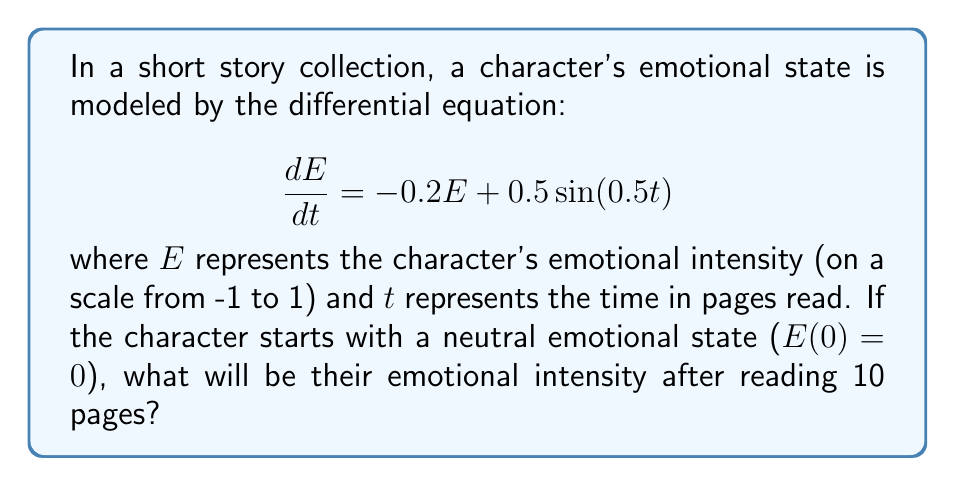Solve this math problem. To solve this problem, we need to use the method for solving first-order linear differential equations. The general form of the equation is:

$$\frac{dE}{dt} + P(t)E = Q(t)$$

In our case, $P(t) = 0.2$ and $Q(t) = 0.5\sin(0.5t)$

1. First, we find the integrating factor:
   $$\mu(t) = e^{\int P(t) dt} = e^{0.2t}$$

2. Multiply both sides of the original equation by the integrating factor:
   $$e^{0.2t}\frac{dE}{dt} + 0.2e^{0.2t}E = 0.5e^{0.2t}\sin(0.5t)$$

3. The left side can be rewritten as the derivative of a product:
   $$\frac{d}{dt}(e^{0.2t}E) = 0.5e^{0.2t}\sin(0.5t)$$

4. Integrate both sides:
   $$e^{0.2t}E = \int 0.5e^{0.2t}\sin(0.5t)dt$$

5. To solve the integral, use integration by parts:
   $$\int 0.5e^{0.2t}\sin(0.5t)dt = 0.5e^{0.2t}(\frac{0.2\sin(0.5t) - 0.5\cos(0.5t)}{0.04 + 0.25}) + C$$

6. Simplify:
   $$e^{0.2t}E = 0.5e^{0.2t}(\frac{0.2\sin(0.5t) - 0.5\cos(0.5t)}{0.29}) + C$$

7. Solve for E:
   $$E = \frac{0.5(0.2\sin(0.5t) - 0.5\cos(0.5t))}{0.29} + Ce^{-0.2t}$$

8. Use the initial condition $E(0) = 0$ to find C:
   $$0 = \frac{0.5(-0.5)}{0.29} + C$$
   $$C = \frac{0.25}{0.29} \approx 0.8621$$

9. The final solution is:
   $$E(t) = \frac{0.5(0.2\sin(0.5t) - 0.5\cos(0.5t))}{0.29} + 0.8621e^{-0.2t}$$

10. To find E(10), substitute t = 10:
    $$E(10) = \frac{0.5(0.2\sin(5) - 0.5\cos(5))}{0.29} + 0.8621e^{-2}$$
Answer: $E(10) \approx 0.2878$ 